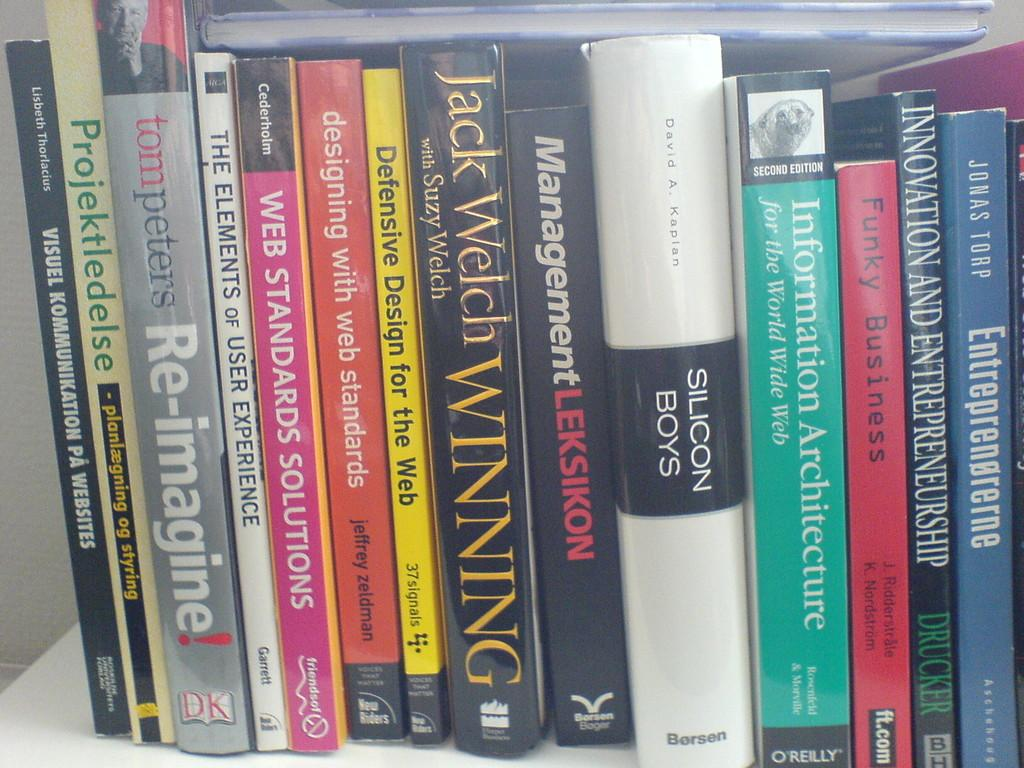<image>
Render a clear and concise summary of the photo. A collection of books standing on their side with on named Silicone Boys. 